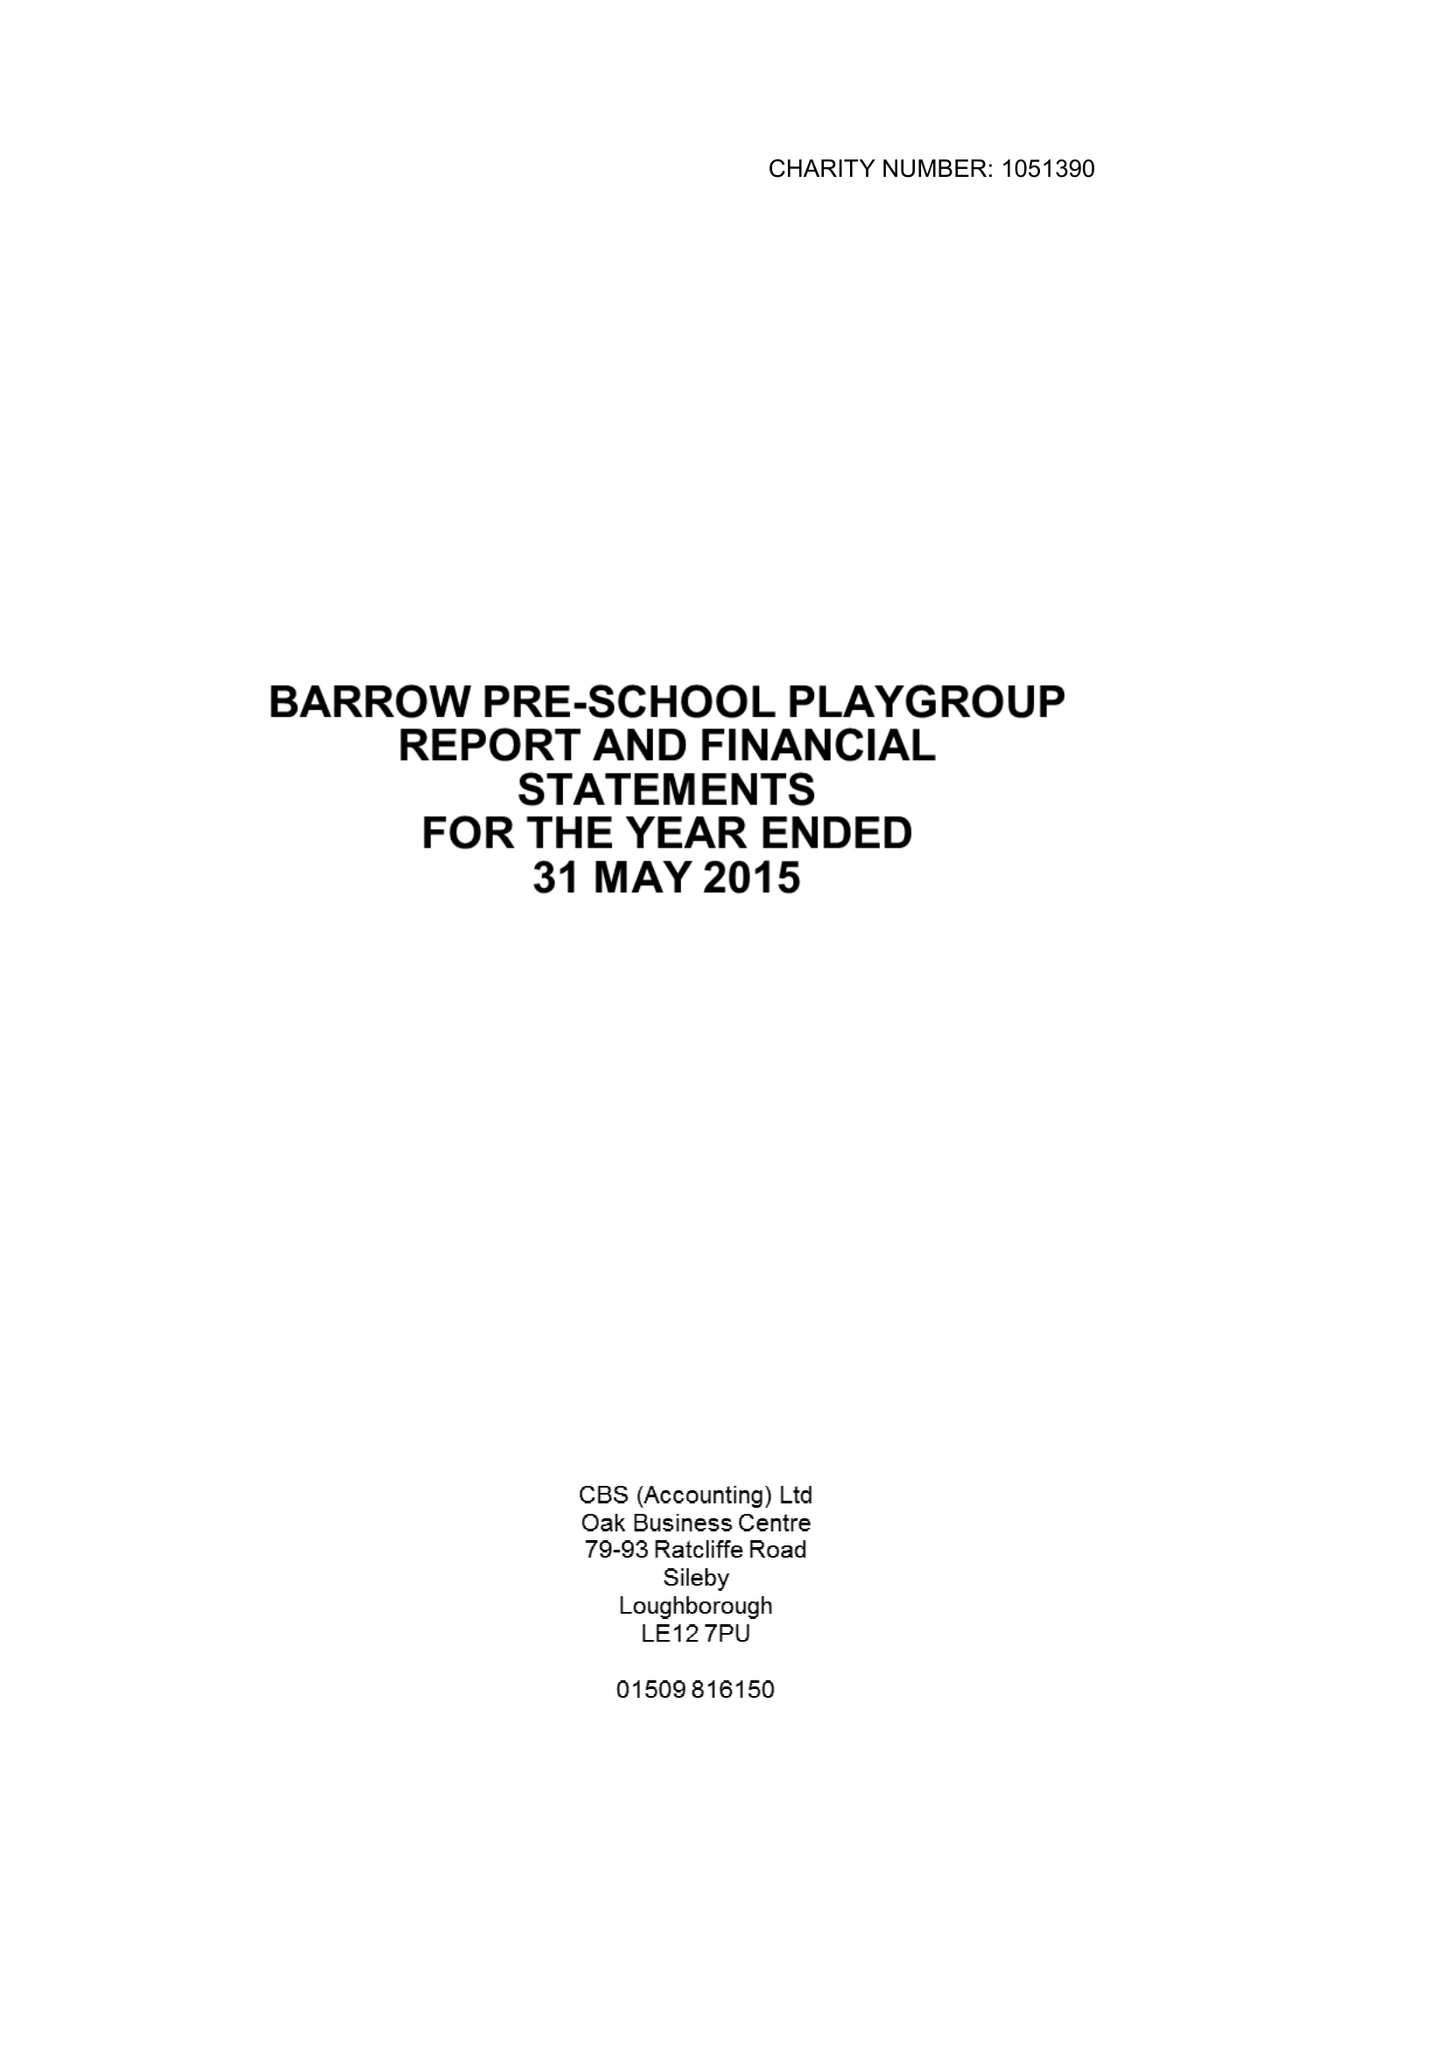What is the value for the address__postcode?
Answer the question using a single word or phrase. LE12 8PB 